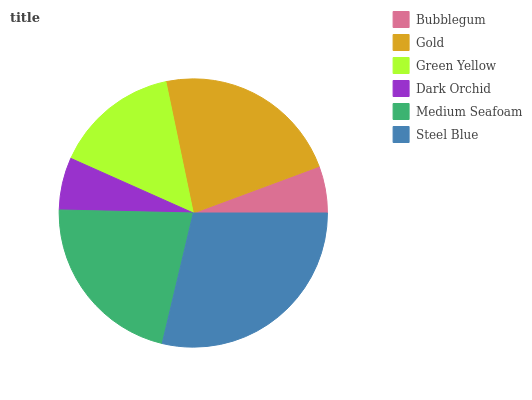Is Bubblegum the minimum?
Answer yes or no. Yes. Is Steel Blue the maximum?
Answer yes or no. Yes. Is Gold the minimum?
Answer yes or no. No. Is Gold the maximum?
Answer yes or no. No. Is Gold greater than Bubblegum?
Answer yes or no. Yes. Is Bubblegum less than Gold?
Answer yes or no. Yes. Is Bubblegum greater than Gold?
Answer yes or no. No. Is Gold less than Bubblegum?
Answer yes or no. No. Is Medium Seafoam the high median?
Answer yes or no. Yes. Is Green Yellow the low median?
Answer yes or no. Yes. Is Bubblegum the high median?
Answer yes or no. No. Is Dark Orchid the low median?
Answer yes or no. No. 